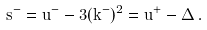Convert formula to latex. <formula><loc_0><loc_0><loc_500><loc_500>s ^ { - } = u ^ { - } - 3 ( k ^ { - } ) ^ { 2 } = u ^ { + } - \Delta \, .</formula> 